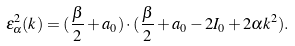<formula> <loc_0><loc_0><loc_500><loc_500>\varepsilon ^ { 2 } _ { \alpha } ( k ) = ( \frac { \beta } { 2 } + a _ { 0 } ) \cdot ( \frac { \beta } { 2 } + a _ { 0 } - 2 I _ { 0 } + 2 \alpha k ^ { 2 } ) .</formula> 